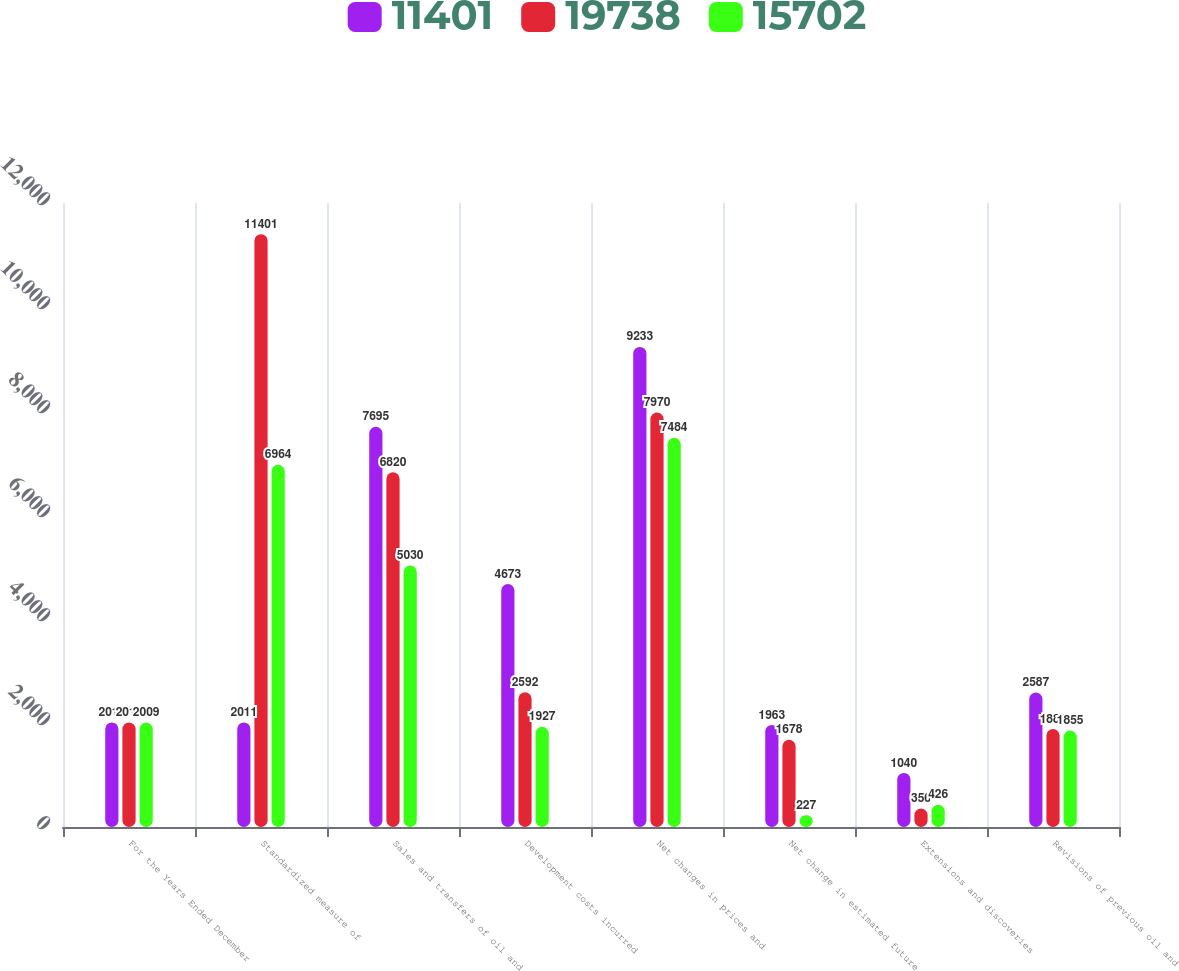Convert chart to OTSL. <chart><loc_0><loc_0><loc_500><loc_500><stacked_bar_chart><ecel><fcel>For the Years Ended December<fcel>Standardized measure of<fcel>Sales and transfers of oil and<fcel>Development costs incurred<fcel>Net changes in prices and<fcel>Net change in estimated future<fcel>Extensions and discoveries<fcel>Revisions of previous oil and<nl><fcel>11401<fcel>2011<fcel>2011<fcel>7695<fcel>4673<fcel>9233<fcel>1963<fcel>1040<fcel>2587<nl><fcel>19738<fcel>2010<fcel>11401<fcel>6820<fcel>2592<fcel>7970<fcel>1678<fcel>356<fcel>1885<nl><fcel>15702<fcel>2009<fcel>6964<fcel>5030<fcel>1927<fcel>7484<fcel>227<fcel>426<fcel>1855<nl></chart> 